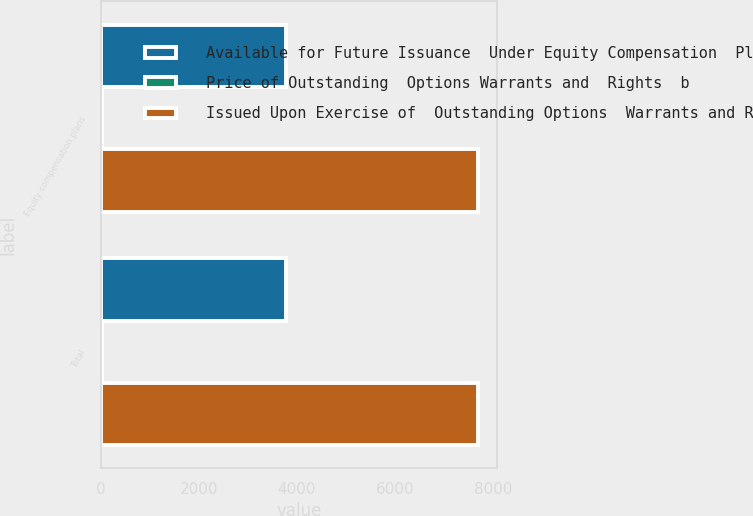Convert chart. <chart><loc_0><loc_0><loc_500><loc_500><stacked_bar_chart><ecel><fcel>Equity compensation plans<fcel>Total<nl><fcel>Available for Future Issuance  Under Equity Compensation  Plans excluding securities  reflected in column a1  c<fcel>3787<fcel>3787<nl><fcel>Price of Outstanding  Options Warrants and  Rights  b<fcel>15.67<fcel>15.67<nl><fcel>Issued Upon Exercise of  Outstanding Options  Warrants and Rights  a<fcel>7697<fcel>7697<nl></chart> 